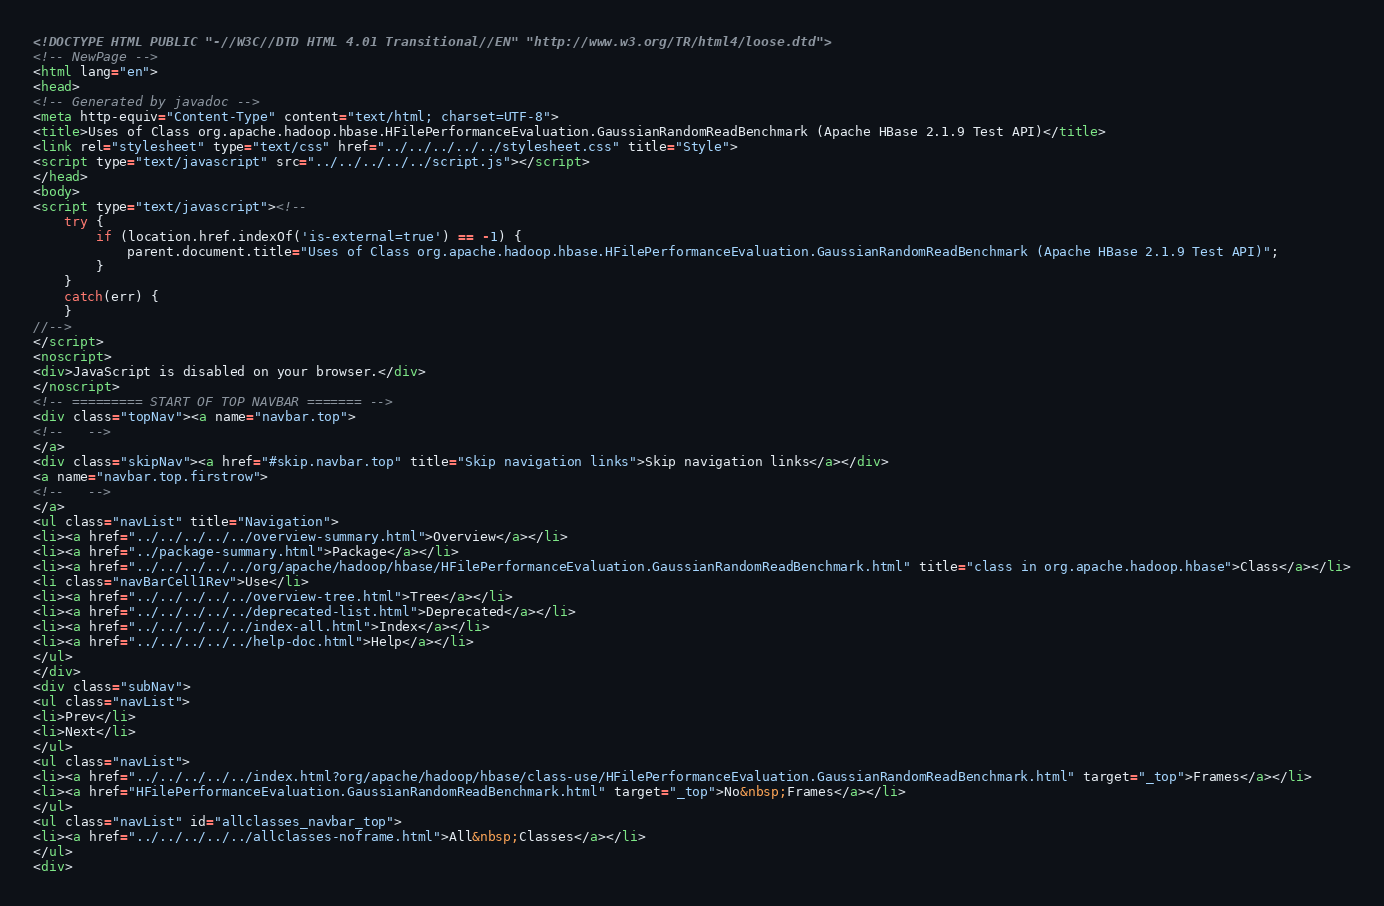<code> <loc_0><loc_0><loc_500><loc_500><_HTML_><!DOCTYPE HTML PUBLIC "-//W3C//DTD HTML 4.01 Transitional//EN" "http://www.w3.org/TR/html4/loose.dtd">
<!-- NewPage -->
<html lang="en">
<head>
<!-- Generated by javadoc -->
<meta http-equiv="Content-Type" content="text/html; charset=UTF-8">
<title>Uses of Class org.apache.hadoop.hbase.HFilePerformanceEvaluation.GaussianRandomReadBenchmark (Apache HBase 2.1.9 Test API)</title>
<link rel="stylesheet" type="text/css" href="../../../../../stylesheet.css" title="Style">
<script type="text/javascript" src="../../../../../script.js"></script>
</head>
<body>
<script type="text/javascript"><!--
    try {
        if (location.href.indexOf('is-external=true') == -1) {
            parent.document.title="Uses of Class org.apache.hadoop.hbase.HFilePerformanceEvaluation.GaussianRandomReadBenchmark (Apache HBase 2.1.9 Test API)";
        }
    }
    catch(err) {
    }
//-->
</script>
<noscript>
<div>JavaScript is disabled on your browser.</div>
</noscript>
<!-- ========= START OF TOP NAVBAR ======= -->
<div class="topNav"><a name="navbar.top">
<!--   -->
</a>
<div class="skipNav"><a href="#skip.navbar.top" title="Skip navigation links">Skip navigation links</a></div>
<a name="navbar.top.firstrow">
<!--   -->
</a>
<ul class="navList" title="Navigation">
<li><a href="../../../../../overview-summary.html">Overview</a></li>
<li><a href="../package-summary.html">Package</a></li>
<li><a href="../../../../../org/apache/hadoop/hbase/HFilePerformanceEvaluation.GaussianRandomReadBenchmark.html" title="class in org.apache.hadoop.hbase">Class</a></li>
<li class="navBarCell1Rev">Use</li>
<li><a href="../../../../../overview-tree.html">Tree</a></li>
<li><a href="../../../../../deprecated-list.html">Deprecated</a></li>
<li><a href="../../../../../index-all.html">Index</a></li>
<li><a href="../../../../../help-doc.html">Help</a></li>
</ul>
</div>
<div class="subNav">
<ul class="navList">
<li>Prev</li>
<li>Next</li>
</ul>
<ul class="navList">
<li><a href="../../../../../index.html?org/apache/hadoop/hbase/class-use/HFilePerformanceEvaluation.GaussianRandomReadBenchmark.html" target="_top">Frames</a></li>
<li><a href="HFilePerformanceEvaluation.GaussianRandomReadBenchmark.html" target="_top">No&nbsp;Frames</a></li>
</ul>
<ul class="navList" id="allclasses_navbar_top">
<li><a href="../../../../../allclasses-noframe.html">All&nbsp;Classes</a></li>
</ul>
<div></code> 